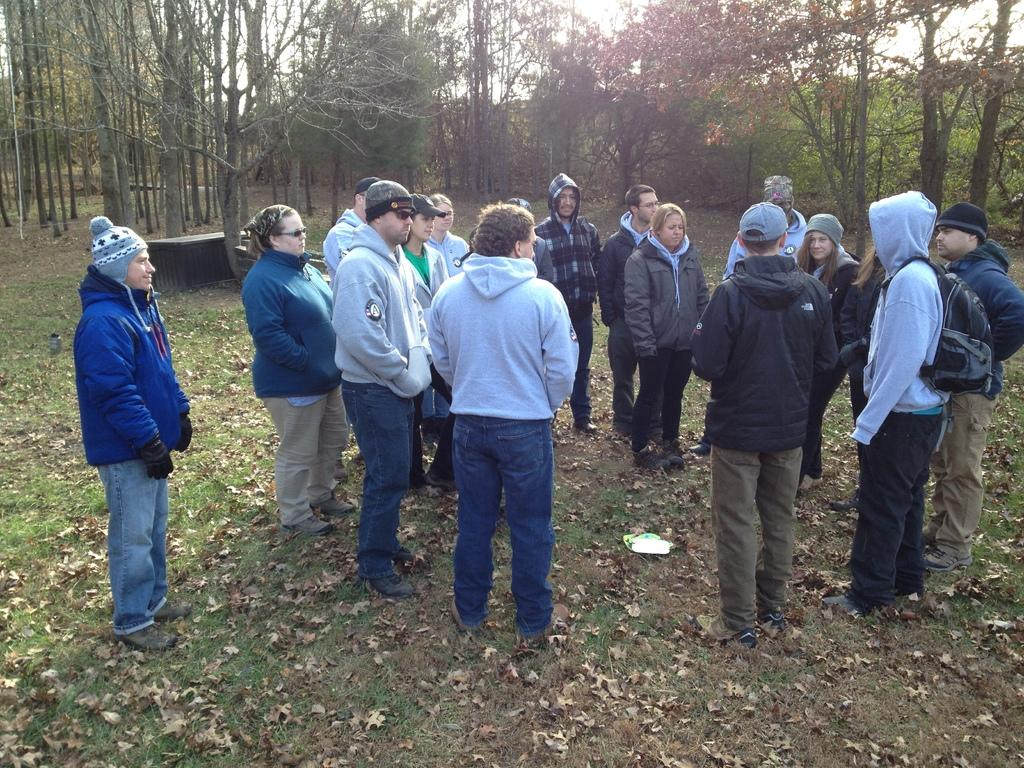What is the main subject of the image? The main subject of the image is a group of people standing. What can be seen on the ground in the image? Dried leaves are lying on the grass in the image. What type of vegetation is present in the image? There are trees with branches and leaves in the image. Can you identify any man-made structures in the image? There appears to be a bench in the image. What type of silk fabric is draped over the table in the image? There is no table or silk fabric present in the image. What kind of feast is being prepared by the group of people in the image? There is no indication of a feast or any food preparation in the image; it simply shows a group of people standing. 